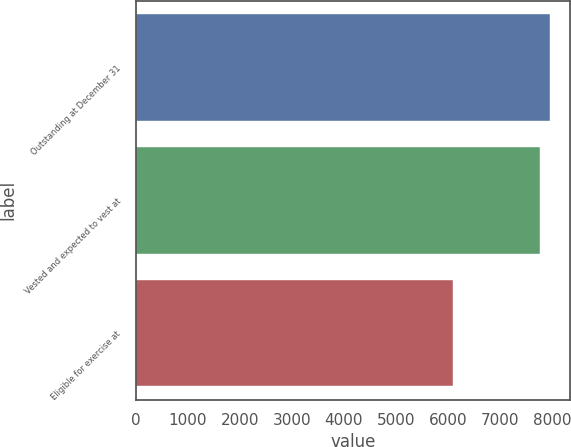<chart> <loc_0><loc_0><loc_500><loc_500><bar_chart><fcel>Outstanding at December 31<fcel>Vested and expected to vest at<fcel>Eligible for exercise at<nl><fcel>7953.3<fcel>7775<fcel>6100<nl></chart> 